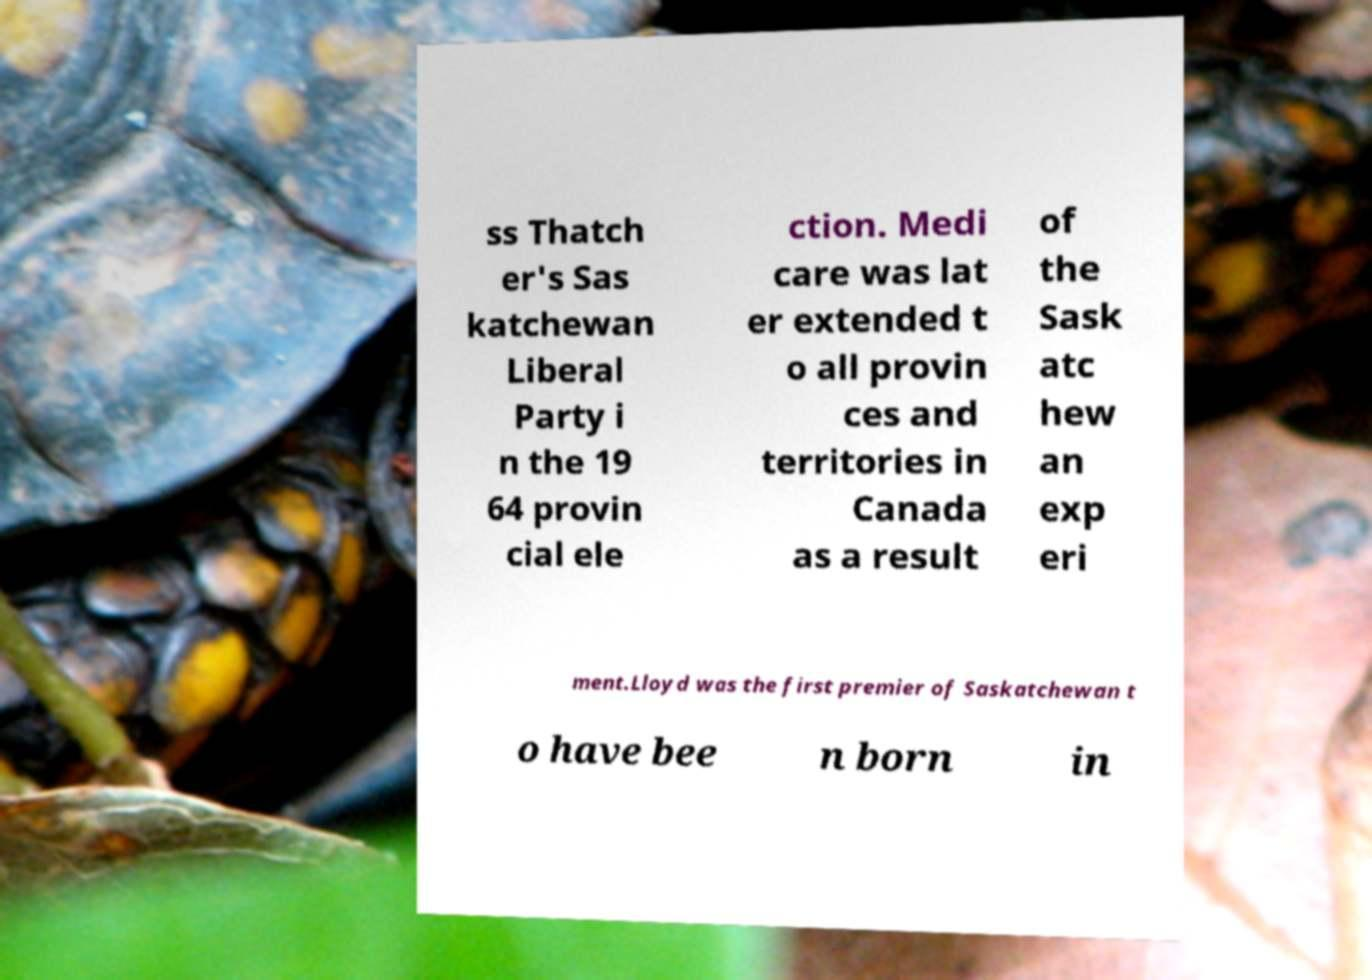There's text embedded in this image that I need extracted. Can you transcribe it verbatim? ss Thatch er's Sas katchewan Liberal Party i n the 19 64 provin cial ele ction. Medi care was lat er extended t o all provin ces and territories in Canada as a result of the Sask atc hew an exp eri ment.Lloyd was the first premier of Saskatchewan t o have bee n born in 